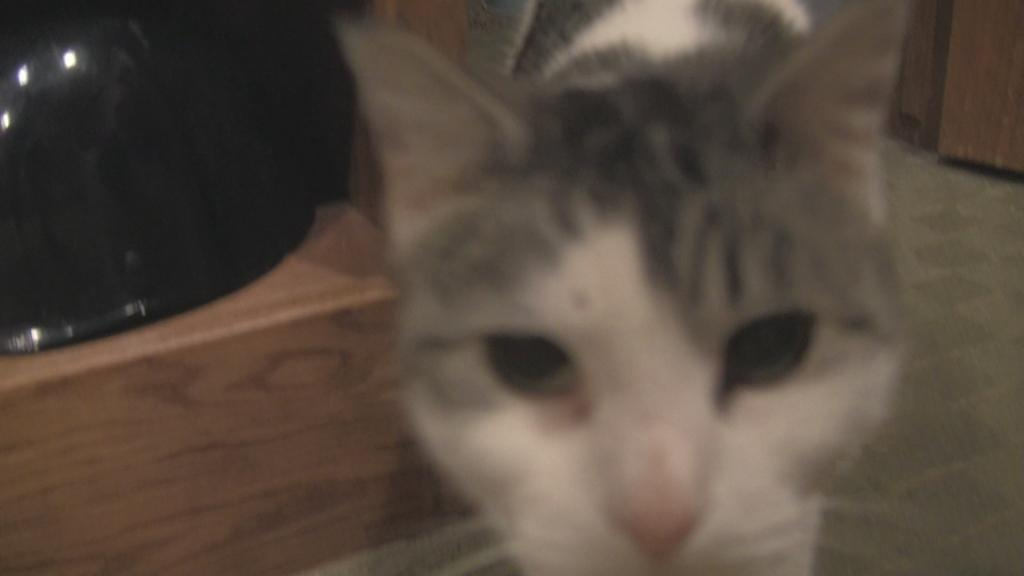What type of animal is in the image? There is a cat in the image. Where is the cat located in the image? The cat is on the floor. Can you describe the black-colored object in the image? There is a black-colored object in the top left corner of the image. How much money is being exchanged between the pigs in the image? There are no pigs present in the image, and no money exchange is depicted. 